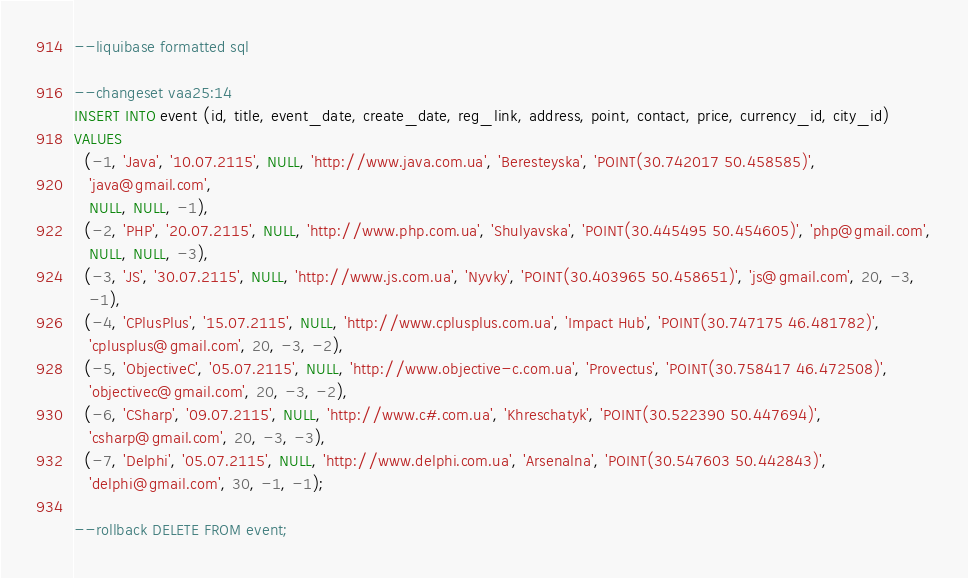<code> <loc_0><loc_0><loc_500><loc_500><_SQL_>--liquibase formatted sql

--changeset vaa25:14
INSERT INTO event (id, title, event_date, create_date, reg_link, address, point, contact, price, currency_id, city_id)
VALUES
  (-1, 'Java', '10.07.2115', NULL, 'http://www.java.com.ua', 'Beresteyska', 'POINT(30.742017 50.458585)',
   'java@gmail.com',
   NULL, NULL, -1),
  (-2, 'PHP', '20.07.2115', NULL, 'http://www.php.com.ua', 'Shulyavska', 'POINT(30.445495 50.454605)', 'php@gmail.com',
   NULL, NULL, -3),
  (-3, 'JS', '30.07.2115', NULL, 'http://www.js.com.ua', 'Nyvky', 'POINT(30.403965 50.458651)', 'js@gmail.com', 20, -3,
   -1),
  (-4, 'CPlusPlus', '15.07.2115', NULL, 'http://www.cplusplus.com.ua', 'Impact Hub', 'POINT(30.747175 46.481782)',
   'cplusplus@gmail.com', 20, -3, -2),
  (-5, 'ObjectiveC', '05.07.2115', NULL, 'http://www.objective-c.com.ua', 'Provectus', 'POINT(30.758417 46.472508)',
   'objectivec@gmail.com', 20, -3, -2),
  (-6, 'CSharp', '09.07.2115', NULL, 'http://www.c#.com.ua', 'Khreschatyk', 'POINT(30.522390 50.447694)',
   'csharp@gmail.com', 20, -3, -3),
  (-7, 'Delphi', '05.07.2115', NULL, 'http://www.delphi.com.ua', 'Arsenalna', 'POINT(30.547603 50.442843)',
   'delphi@gmail.com', 30, -1, -1);

--rollback DELETE FROM event;</code> 